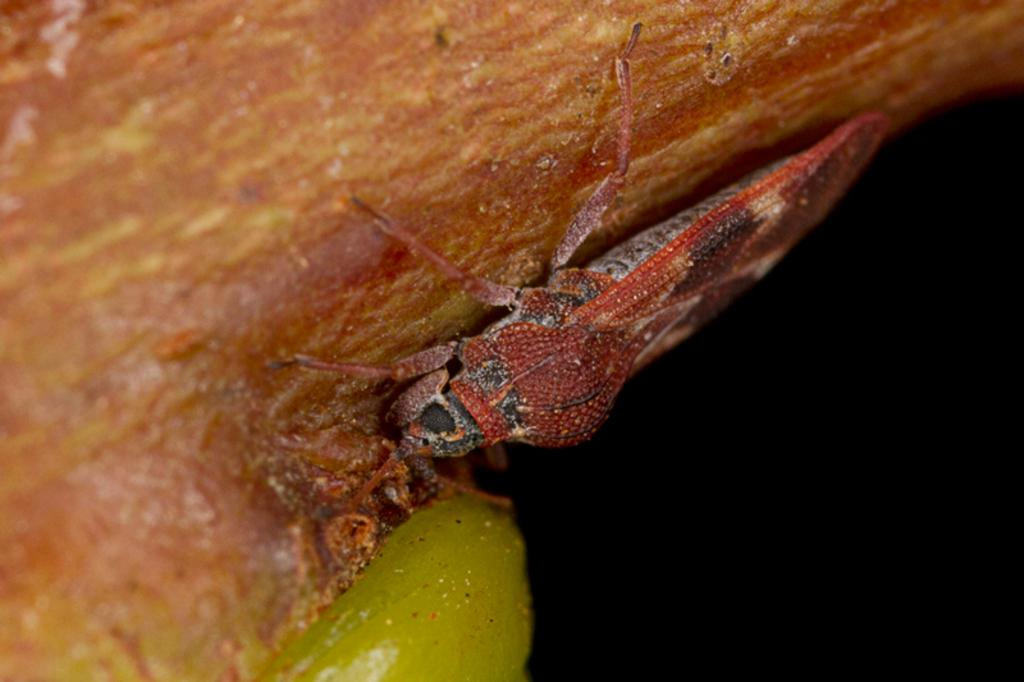What type of creature can be seen in the image? There is an insect in the image. What is the insect located on? The insect is on brown-colored food. Can you see any hands holding the insect in the image? There are no hands visible in the image, and the insect is on brown-colored food, not being held by anyone. 